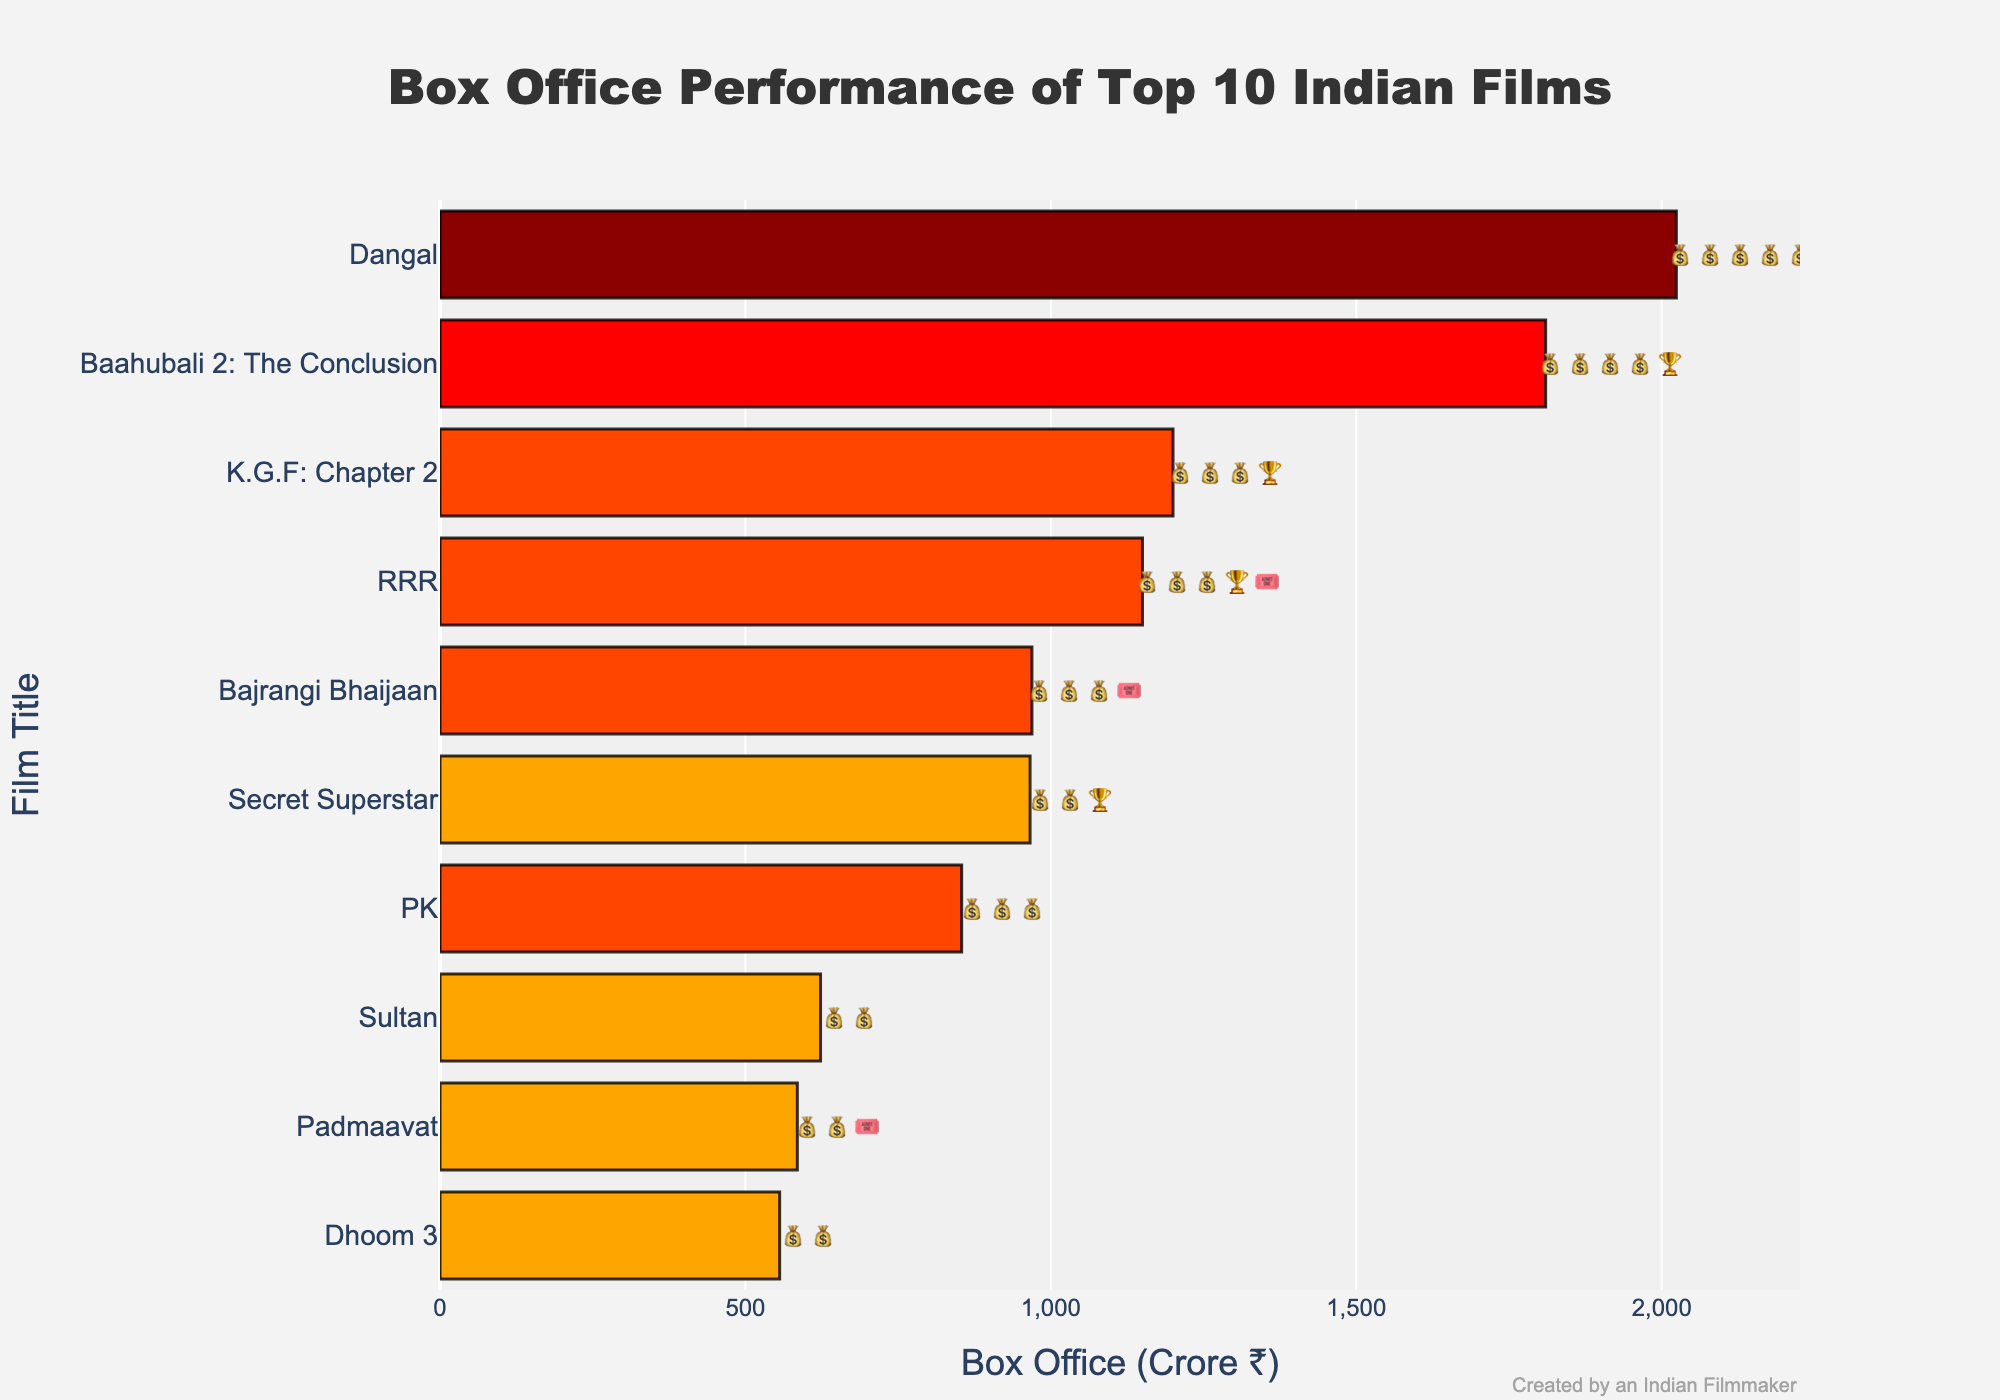What is the title of the chart? The title of the chart is usually found at the top of the figure. Here, the title reads, "Box Office Performance of Top 10 Indian Films".
Answer: Box Office Performance of Top 10 Indian Films Which film has the highest box office revenue? The film with the highest box office revenue is located at the top of the horizontal bars. "Dangal" is shown at the top with a box office of ₹2024 Crore.
Answer: Dangal What is the box office revenue of "PK"? Find "PK" on the y-axis and trace horizontally to the x-axis to see the box office revenue, which is ₹854 Crore.
Answer: ₹854 Crore How many films have a rating of 💰💰💰? Count the number of films with the text 💰💰💰 next to their bars. There are 3 films: "PK", "Bajrangi Bhaijaan", and "RRR".
Answer: 3 Which film has a rating of 💰💰💰🏆🎟️? The rating 💰💰💰🏆🎟️ is unique and found on the bar corresponding to "RRR".
Answer: RRR What is the difference in box office revenue between "Dangal" and "Baahubali 2: The Conclusion"? Subtract the box office revenue of "Baahubali 2: The Conclusion" (₹1810 Crore) from that of "Dangal" (₹2024 Crore). So, 2024 - 1810 = 214.
Answer: ₹214 Crore What is the average box office revenue of all the films? Add up the box office revenues of all the films and divide by the number of films: (2024 + 1810 + 1200 + 1150 + 854 + 969 + 966 + 623 + 585 + 556) / 10 = 10,737 / 10 = 1,073.7.
Answer: ₹1073.7 Crore Which film has the lowest box office revenue? The film at the bottom of the chart/bar plot has the lowest box office revenue, which is "Dhoom 3" with ₹556 Crore.
Answer: Dhoom 3 How many films have achieved the highest rating 💰💰💰💰💰? Count the number of films with the rating 💰💰💰💰💰. Only "Dangal" has this rating.
Answer: 1 Which film has both an award 🏆 and a crowd rating 🎟️ in its rating? Look for the film bar with both 🏆 and 🎟️ in its rating. "RRR" fulfills this condition with the rating 💰💰💰🏆🎟️.
Answer: RRR 